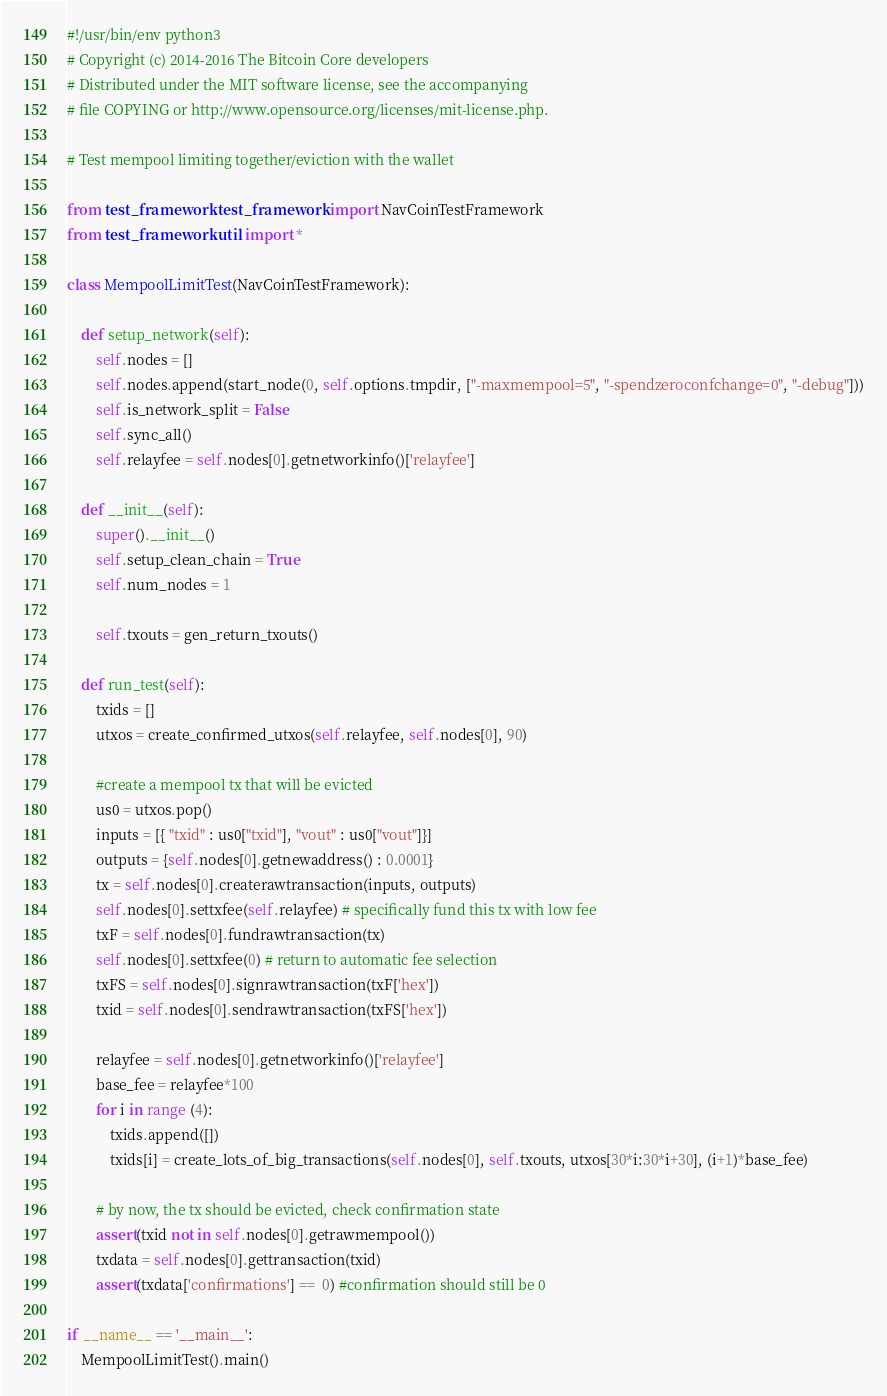Convert code to text. <code><loc_0><loc_0><loc_500><loc_500><_Python_>#!/usr/bin/env python3
# Copyright (c) 2014-2016 The Bitcoin Core developers
# Distributed under the MIT software license, see the accompanying
# file COPYING or http://www.opensource.org/licenses/mit-license.php.

# Test mempool limiting together/eviction with the wallet

from test_framework.test_framework import NavCoinTestFramework
from test_framework.util import *

class MempoolLimitTest(NavCoinTestFramework):

    def setup_network(self):
        self.nodes = []
        self.nodes.append(start_node(0, self.options.tmpdir, ["-maxmempool=5", "-spendzeroconfchange=0", "-debug"]))
        self.is_network_split = False
        self.sync_all()
        self.relayfee = self.nodes[0].getnetworkinfo()['relayfee']

    def __init__(self):
        super().__init__()
        self.setup_clean_chain = True
        self.num_nodes = 1

        self.txouts = gen_return_txouts()

    def run_test(self):
        txids = []
        utxos = create_confirmed_utxos(self.relayfee, self.nodes[0], 90)

        #create a mempool tx that will be evicted
        us0 = utxos.pop()
        inputs = [{ "txid" : us0["txid"], "vout" : us0["vout"]}]
        outputs = {self.nodes[0].getnewaddress() : 0.0001}
        tx = self.nodes[0].createrawtransaction(inputs, outputs)
        self.nodes[0].settxfee(self.relayfee) # specifically fund this tx with low fee
        txF = self.nodes[0].fundrawtransaction(tx)
        self.nodes[0].settxfee(0) # return to automatic fee selection
        txFS = self.nodes[0].signrawtransaction(txF['hex'])
        txid = self.nodes[0].sendrawtransaction(txFS['hex'])

        relayfee = self.nodes[0].getnetworkinfo()['relayfee']
        base_fee = relayfee*100
        for i in range (4):
            txids.append([])
            txids[i] = create_lots_of_big_transactions(self.nodes[0], self.txouts, utxos[30*i:30*i+30], (i+1)*base_fee)

        # by now, the tx should be evicted, check confirmation state
        assert(txid not in self.nodes[0].getrawmempool())
        txdata = self.nodes[0].gettransaction(txid)
        assert(txdata['confirmations'] ==  0) #confirmation should still be 0

if __name__ == '__main__':
    MempoolLimitTest().main()
</code> 